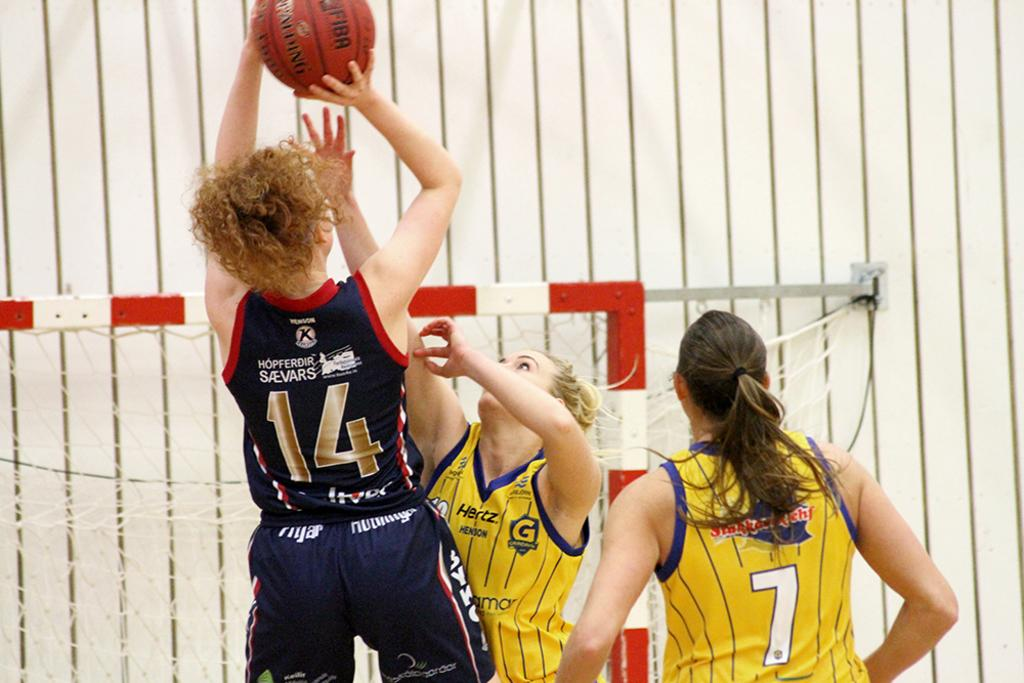Provide a one-sentence caption for the provided image. Player number 14 shoots a basketball over the outstretched hand of a defender. 